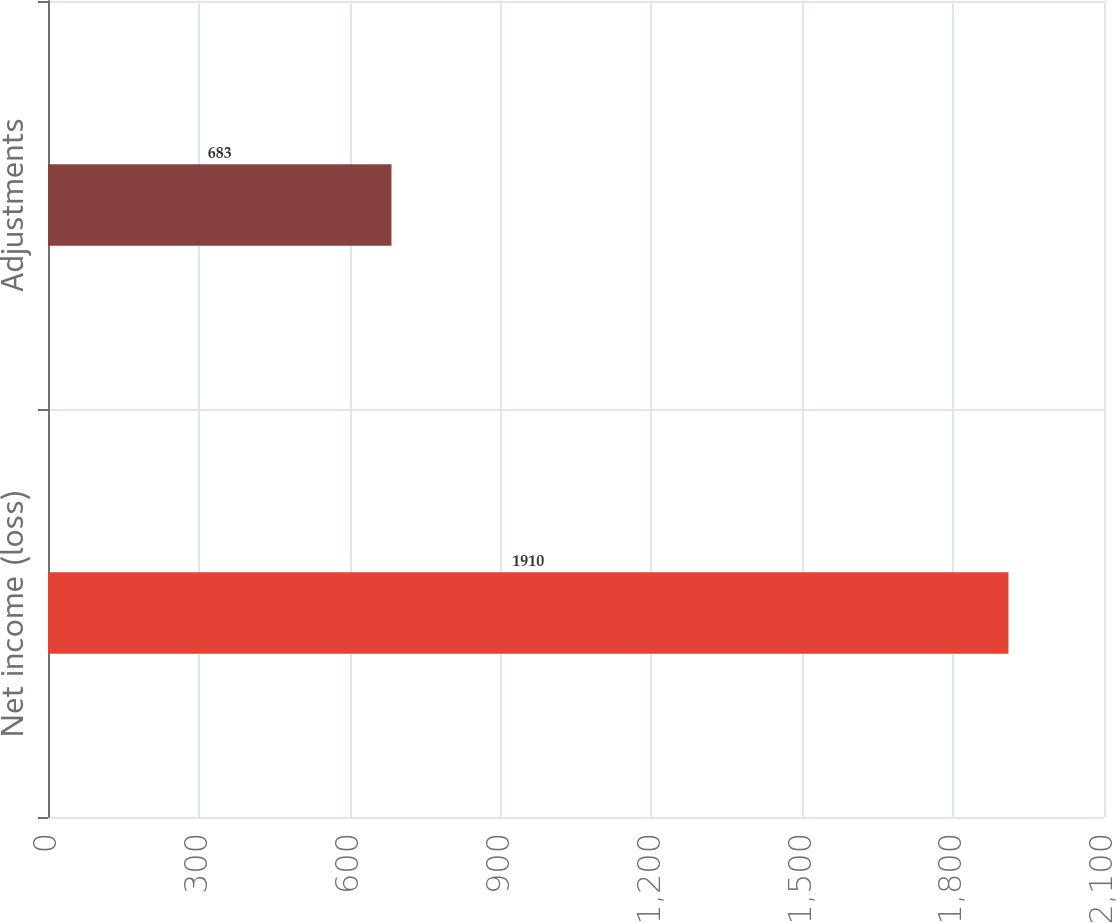Convert chart to OTSL. <chart><loc_0><loc_0><loc_500><loc_500><bar_chart><fcel>Net income (loss)<fcel>Adjustments<nl><fcel>1910<fcel>683<nl></chart> 